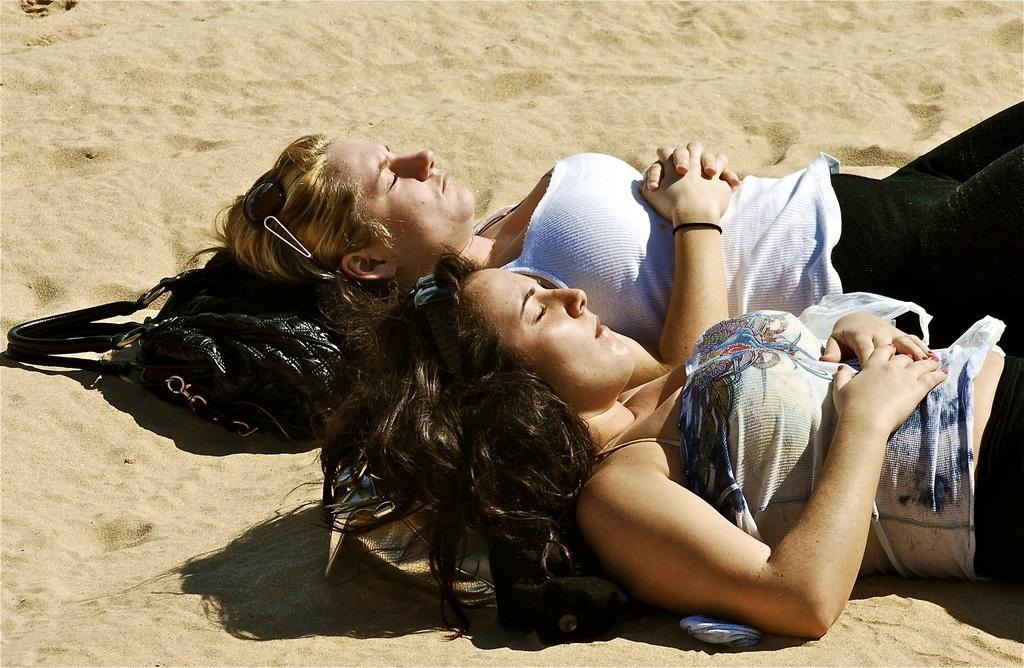Who is present in the image? There are women in the image. What are the women doing in the image? The women are sleeping. Where are the women located in the image? The women are on the sand. What type of iron can be seen in the image? There is no iron present in the image. Can you describe the window in the image? There is no window present in the image. 